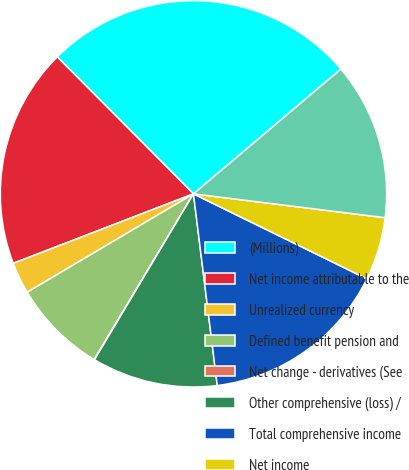Convert chart. <chart><loc_0><loc_0><loc_500><loc_500><pie_chart><fcel>(Millions)<fcel>Net income attributable to the<fcel>Unrealized currency<fcel>Defined benefit pension and<fcel>Net change - derivatives (See<fcel>Other comprehensive (loss) /<fcel>Total comprehensive income<fcel>Net income<fcel>Comprehensive income<nl><fcel>26.28%<fcel>18.4%<fcel>2.65%<fcel>7.9%<fcel>0.03%<fcel>10.53%<fcel>15.78%<fcel>5.28%<fcel>13.15%<nl></chart> 